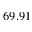Convert formula to latex. <formula><loc_0><loc_0><loc_500><loc_500>6 9 . 9 1</formula> 